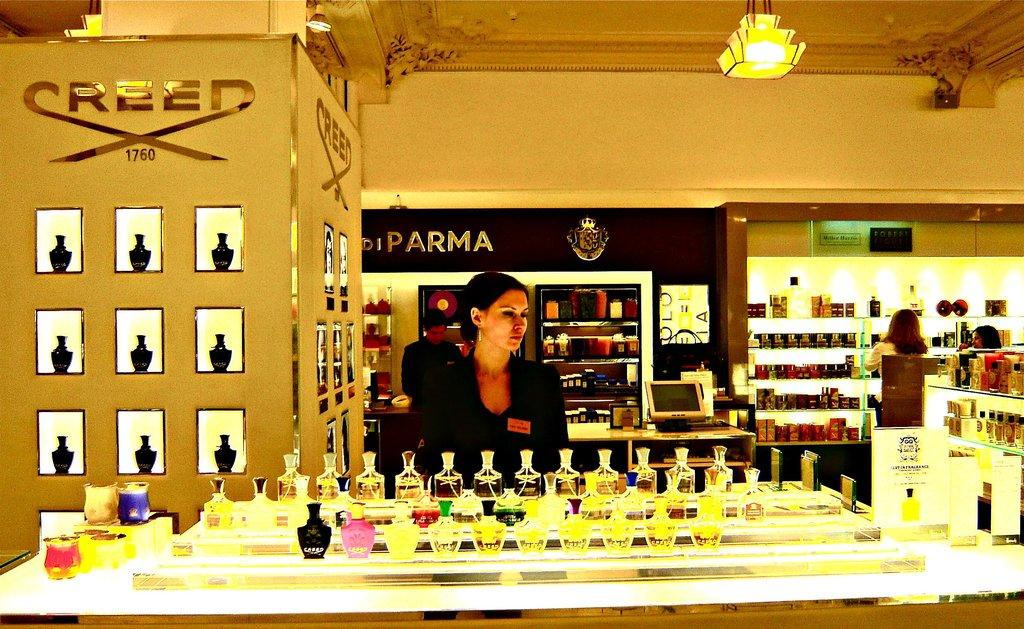<image>
Relay a brief, clear account of the picture shown. A woman in a perfume store with the word Creed on the wall behind her. 